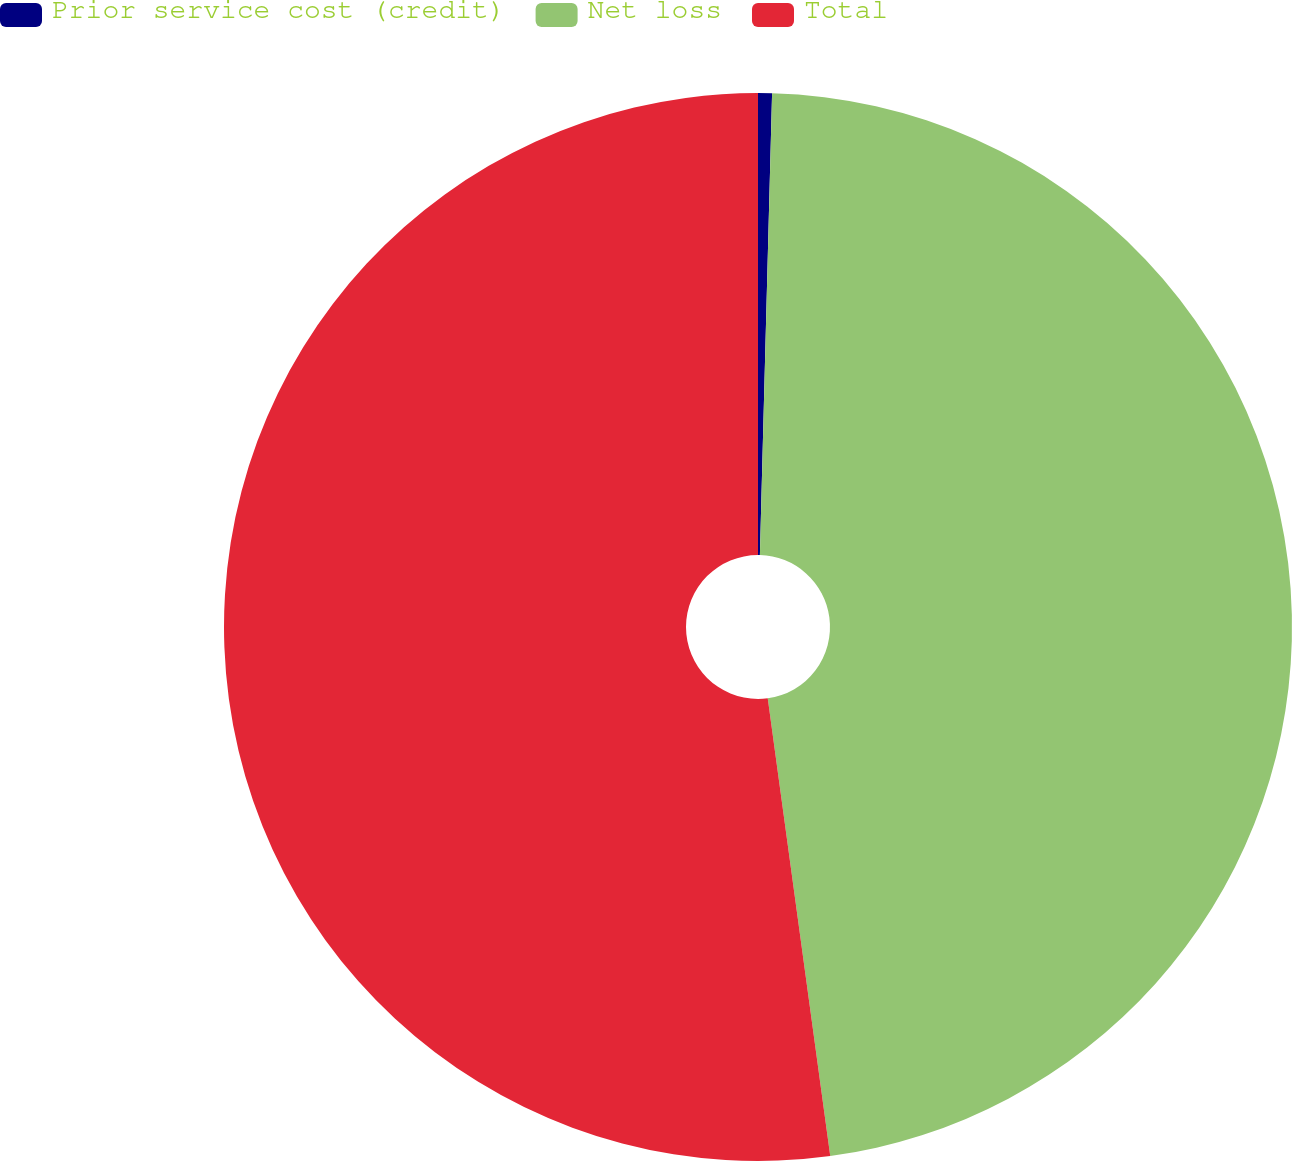Convert chart. <chart><loc_0><loc_0><loc_500><loc_500><pie_chart><fcel>Prior service cost (credit)<fcel>Net loss<fcel>Total<nl><fcel>0.42%<fcel>47.42%<fcel>52.16%<nl></chart> 